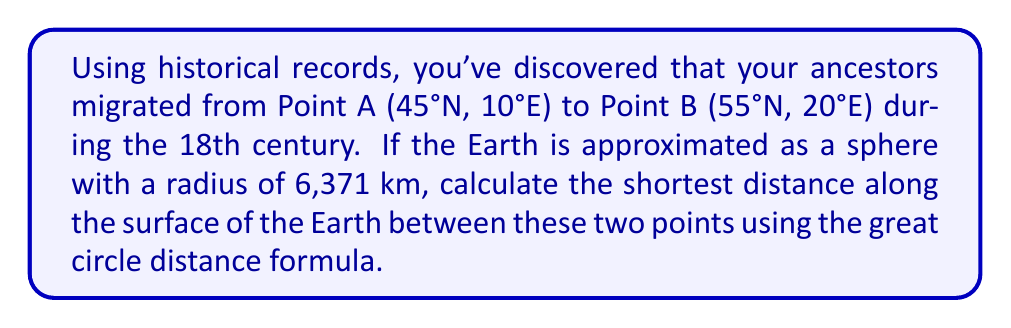What is the answer to this math problem? To solve this problem, we'll use the great circle distance formula, which gives the shortest distance between two points on the surface of a sphere. The formula is:

$$d = r \cdot \arccos(\sin(\phi_1) \cdot \sin(\phi_2) + \cos(\phi_1) \cdot \cos(\phi_2) \cdot \cos(\Delta \lambda))$$

Where:
- $d$ is the distance
- $r$ is the radius of the Earth
- $\phi_1$ and $\phi_2$ are the latitudes of points 1 and 2 in radians
- $\Delta \lambda$ is the absolute difference in longitude in radians

Step 1: Convert latitudes and longitudes from degrees to radians
$\phi_1 = 45° \cdot \frac{\pi}{180°} = 0.7854$ radians
$\phi_2 = 55° \cdot \frac{\pi}{180°} = 0.9599$ radians
$\Delta \lambda = (20° - 10°) \cdot \frac{\pi}{180°} = 0.1745$ radians

Step 2: Apply the formula
$$\begin{align}
d &= 6371 \cdot \arccos(\sin(0.7854) \cdot \sin(0.9599) + \cos(0.7854) \cdot \cos(0.9599) \cdot \cos(0.1745)) \\
&= 6371 \cdot \arccos(0.7071 \cdot 0.8192 + 0.7071 \cdot 0.5736 \cdot 0.9848) \\
&= 6371 \cdot \arccos(0.5792 + 0.3991) \\
&= 6371 \cdot \arccos(0.9783) \\
&= 6371 \cdot 0.2079 \\
&= 1324.44 \text{ km}
\end{align}$$
Answer: The shortest distance along the surface of the Earth between the two points is approximately 1,324 km. 